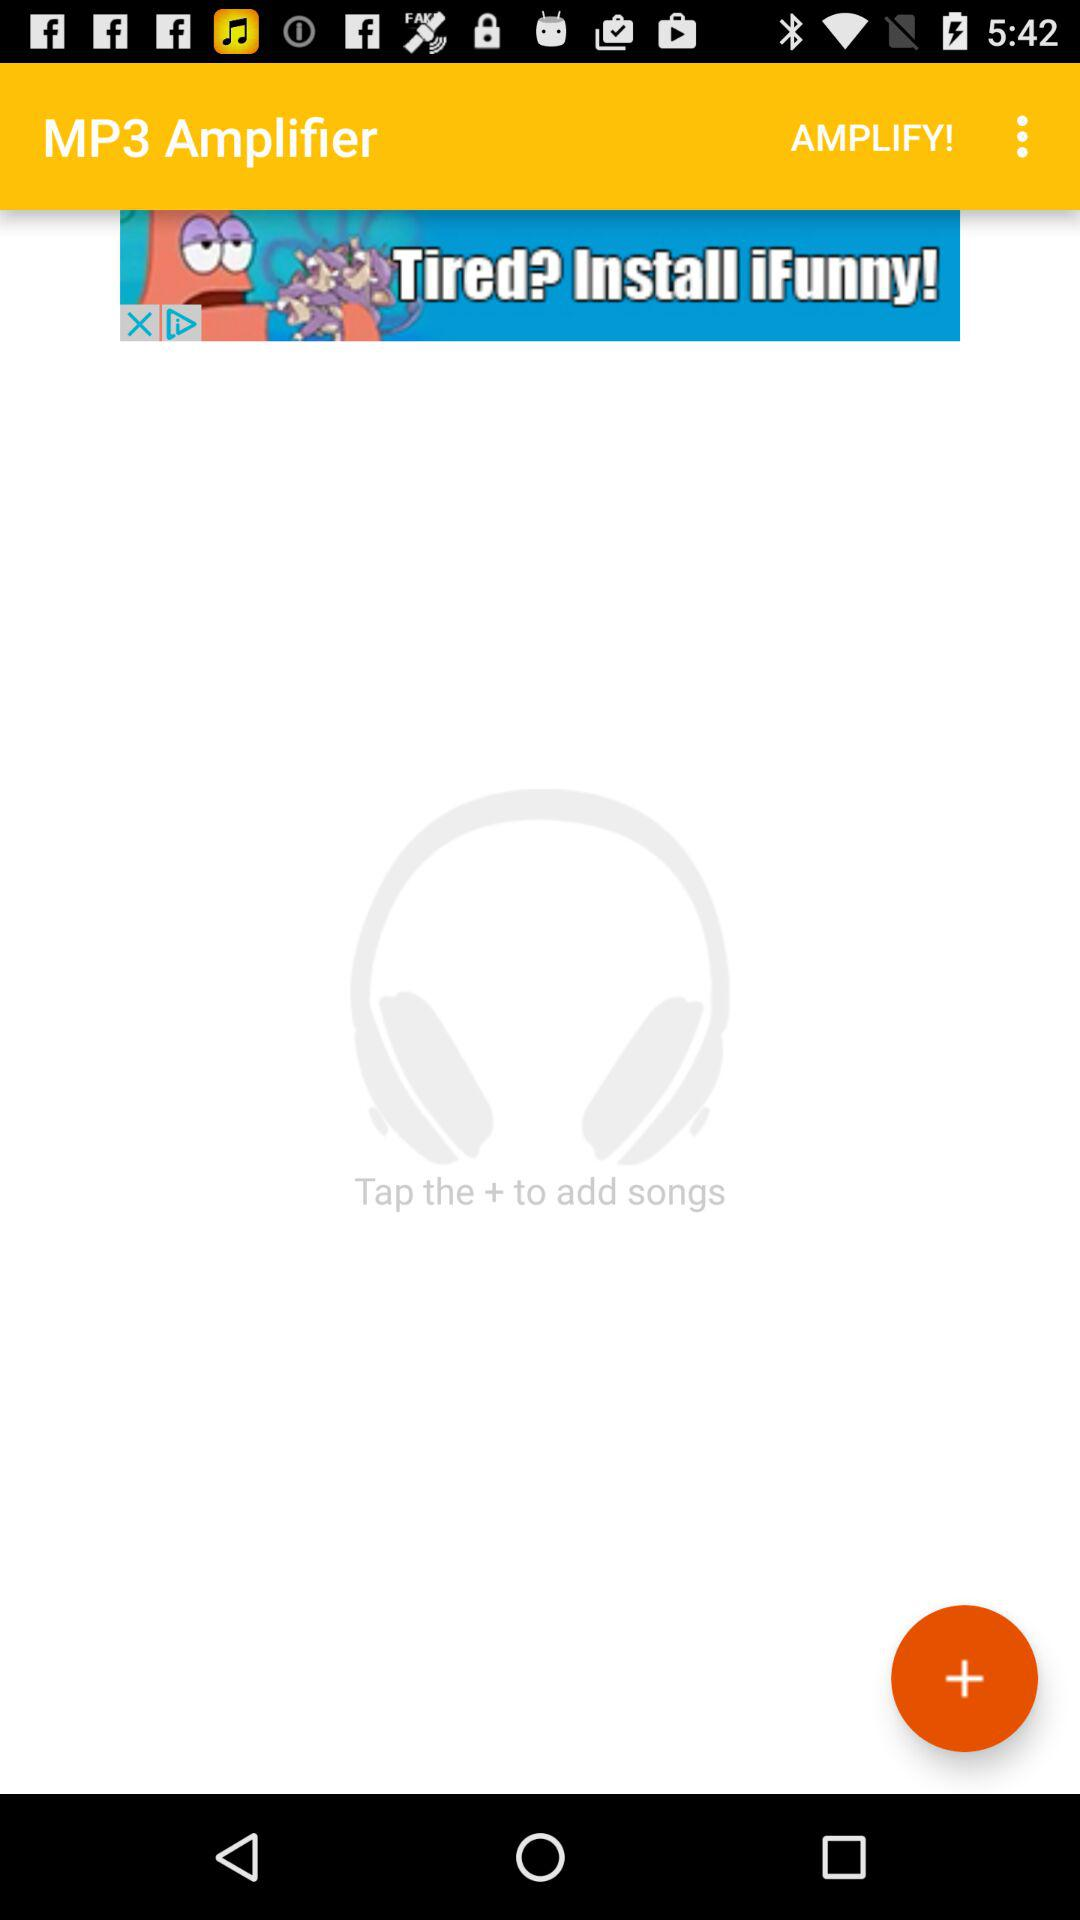What is the application name? The application name is "MP3 Amplifier". 